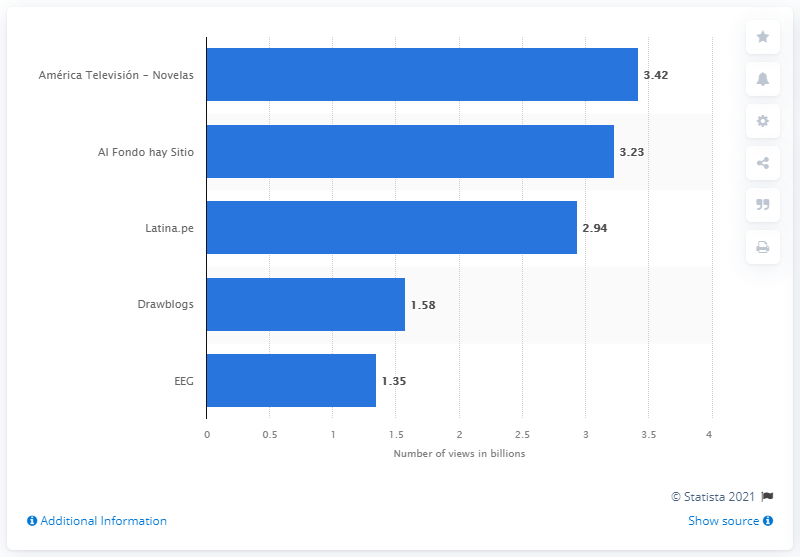Specify some key components in this picture. As of March 2021, Latina.pe had 3,230 views. According to data available as of March 2021, America Televisi3n - Novelas had 3.42 million views on YouTube. 